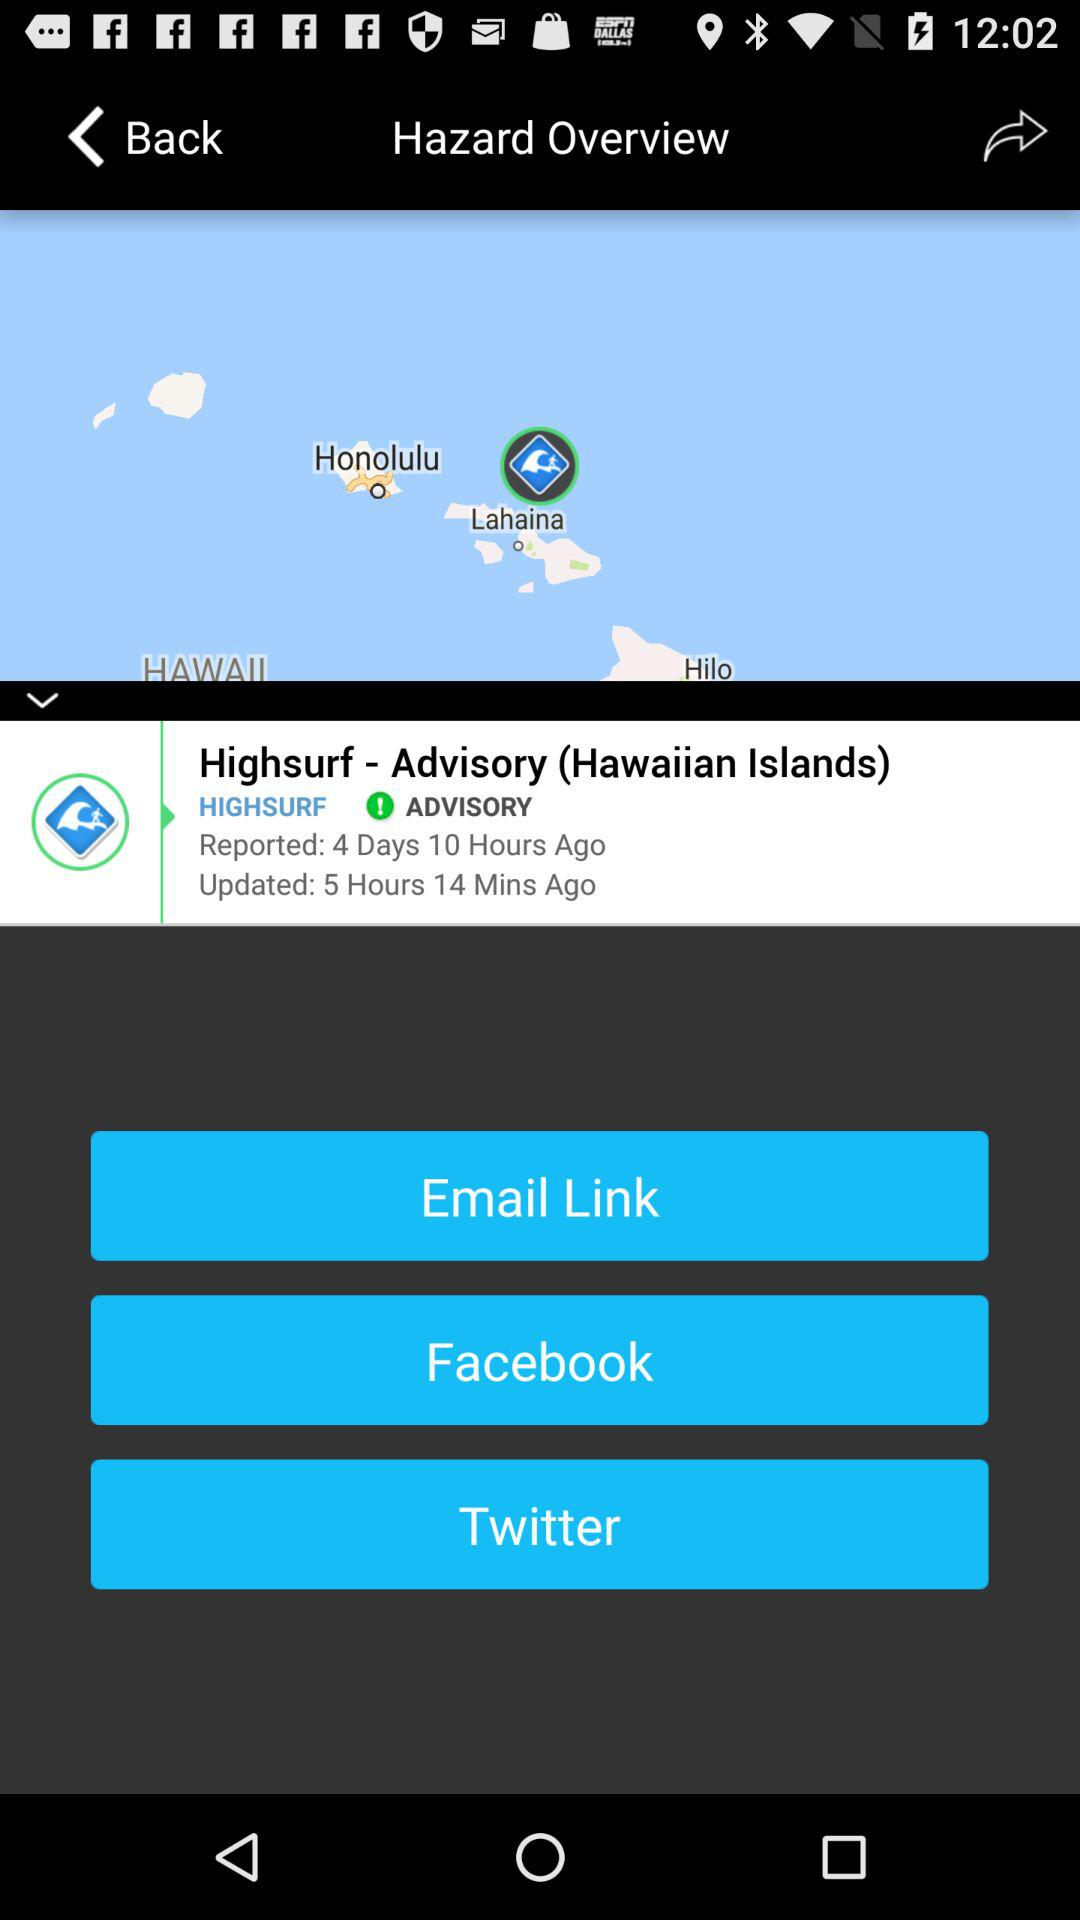What is the island name? The name of the island is Hawaiian. 